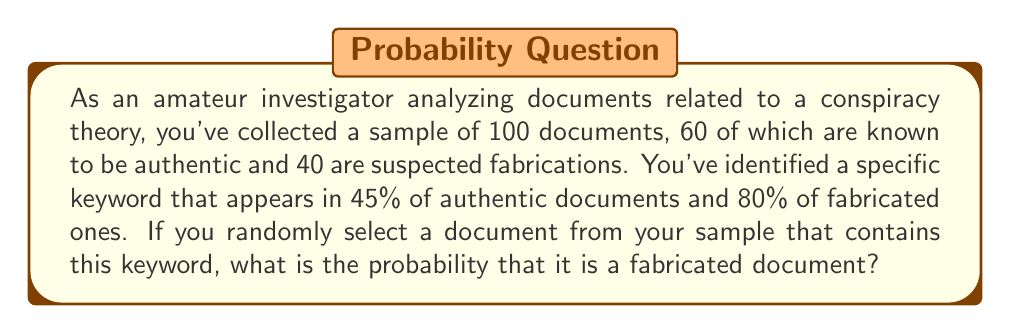Give your solution to this math problem. Let's approach this using Bayes' Theorem. We'll define the following events:

$F$: The document is fabricated
$K$: The document contains the keyword

We want to find $P(F|K)$, the probability that a document is fabricated given that it contains the keyword.

Bayes' Theorem states:

$$P(F|K) = \frac{P(K|F) \cdot P(F)}{P(K)}$$

We know:
$P(K|F) = 0.80$ (80% of fabricated documents contain the keyword)
$P(F) = 40/100 = 0.40$ (40% of the documents are fabricated)

To find $P(K)$, we use the law of total probability:

$$P(K) = P(K|F) \cdot P(F) + P(K|A) \cdot P(A)$$

Where $A$ is the event that the document is authentic.

$P(K|A) = 0.45$ (45% of authentic documents contain the keyword)
$P(A) = 60/100 = 0.60$ (60% of the documents are authentic)

So:
$$P(K) = 0.80 \cdot 0.40 + 0.45 \cdot 0.60 = 0.32 + 0.27 = 0.59$$

Now we can apply Bayes' Theorem:

$$P(F|K) = \frac{0.80 \cdot 0.40}{0.59} \approx 0.5424$$
Answer: The probability that a randomly selected document containing the keyword is fabricated is approximately 0.5424 or 54.24%. 